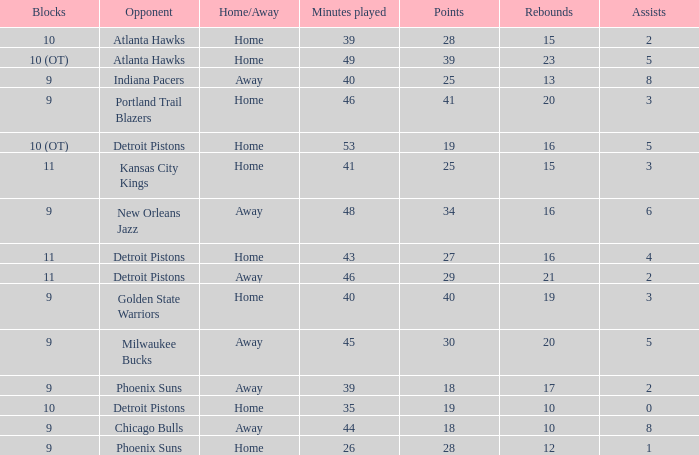How many minutes were played when there were 18 points and the opponent was Chicago Bulls? 1.0. 